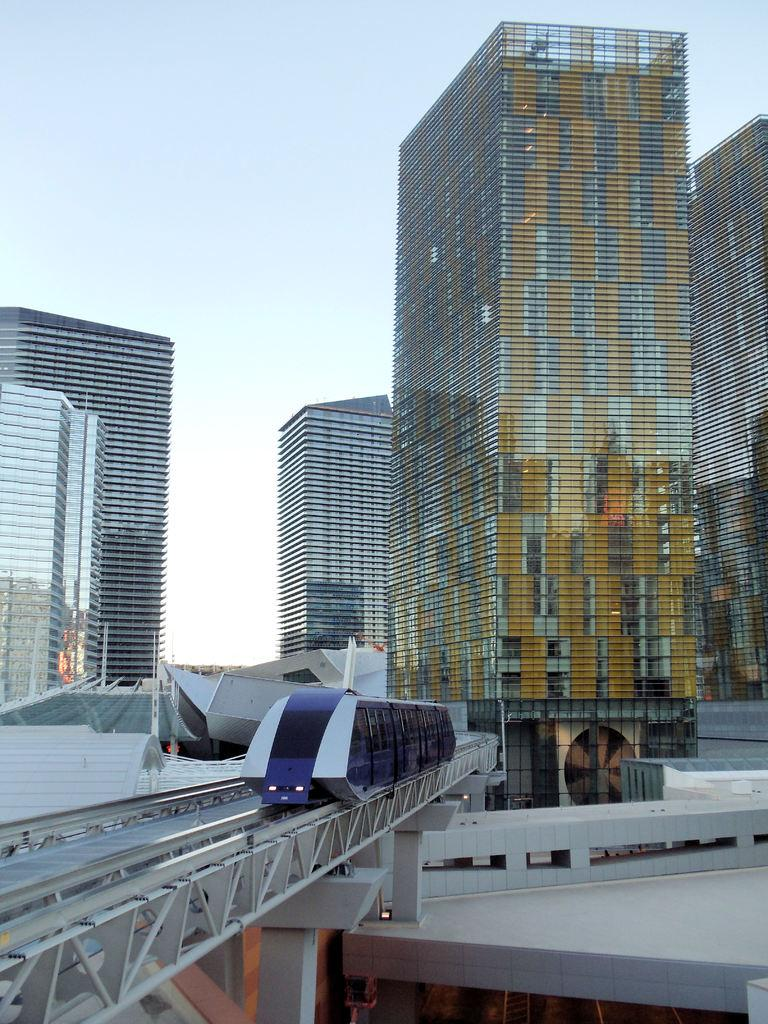What is the main subject of the image? There is a train in the image. Where is the train located? The train is on a railway track. What is the railway track situated on? The railway track is on a bridge. What supports the bridge? There are pillars supporting the bridge. What can be seen in the background of the image? There are many buildings and the sky visible in the background. What type of beef is being served in the image? There is no beef present in the image; it features a train on a bridge. Is there a crown visible on the train in the image? There is no crown present on the train in the image. 